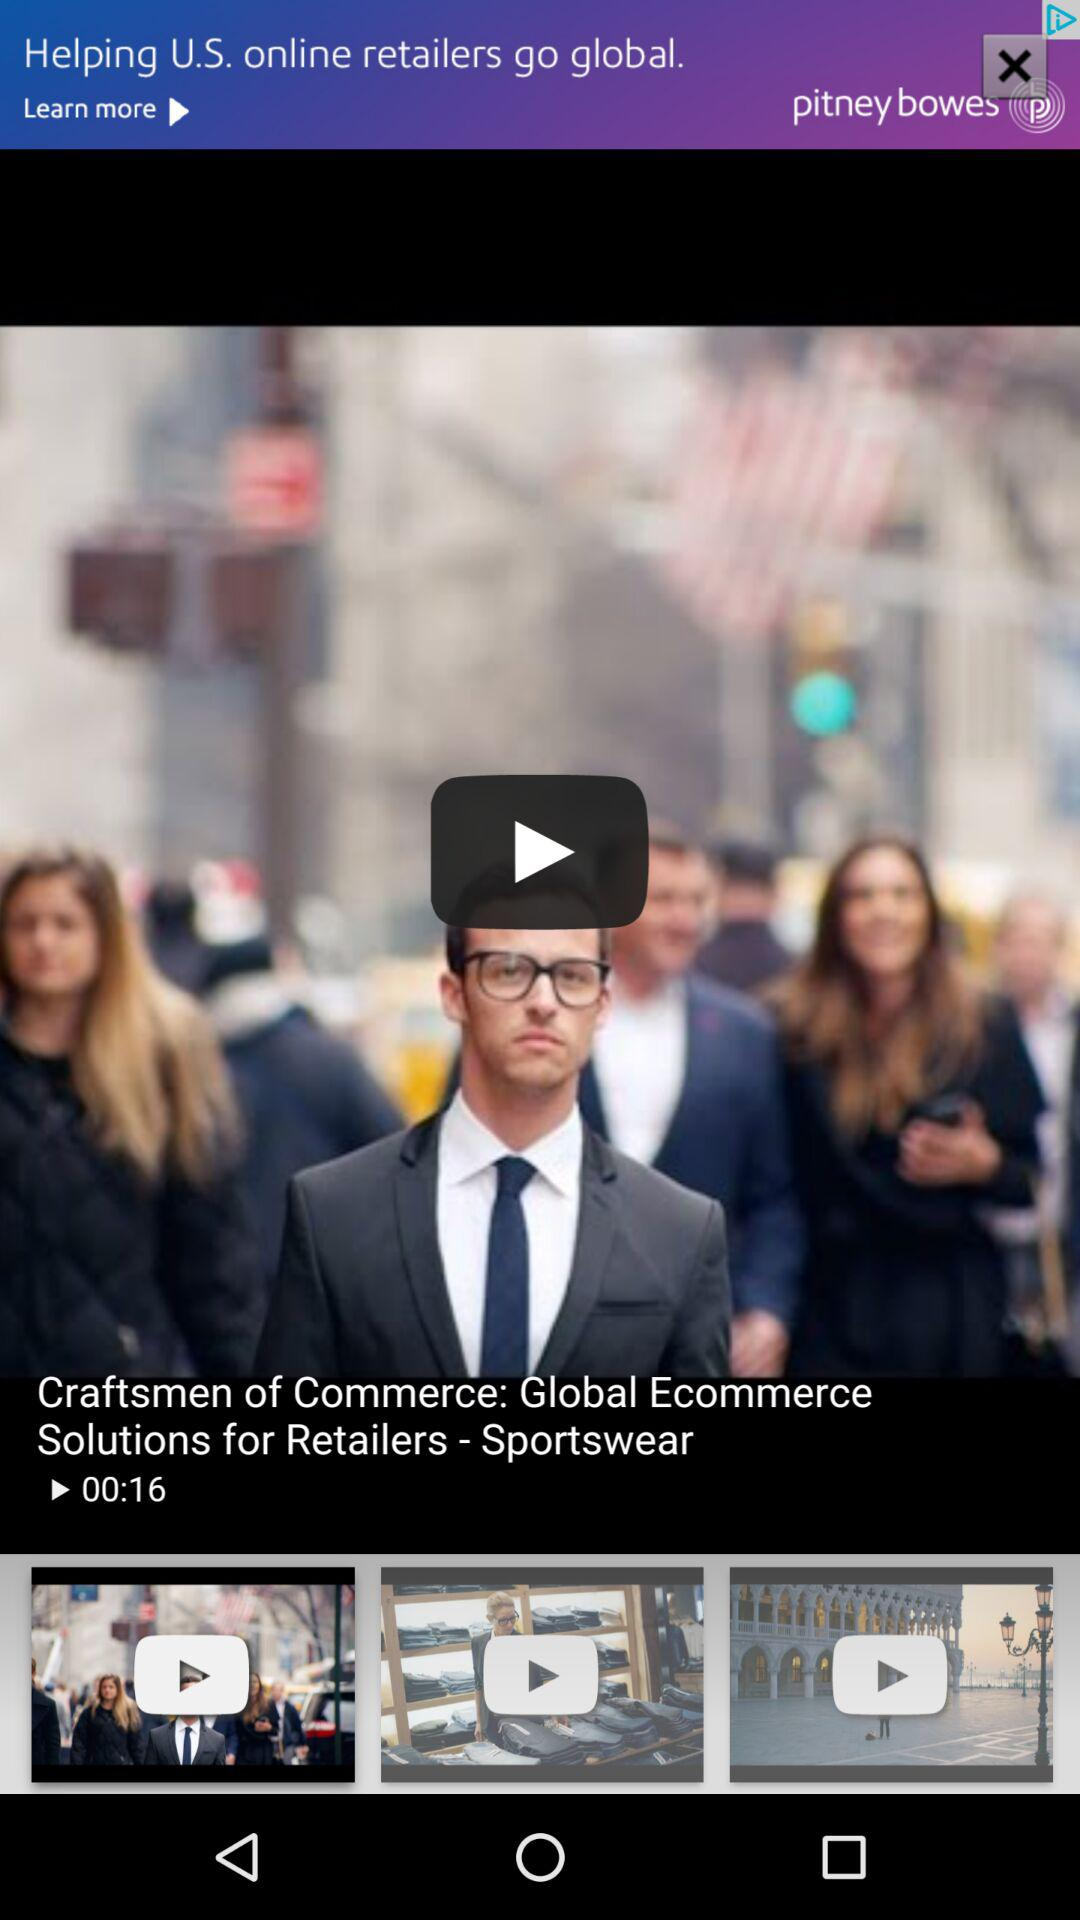What is the duration of the video? The duration of the video is 16 seconds. 